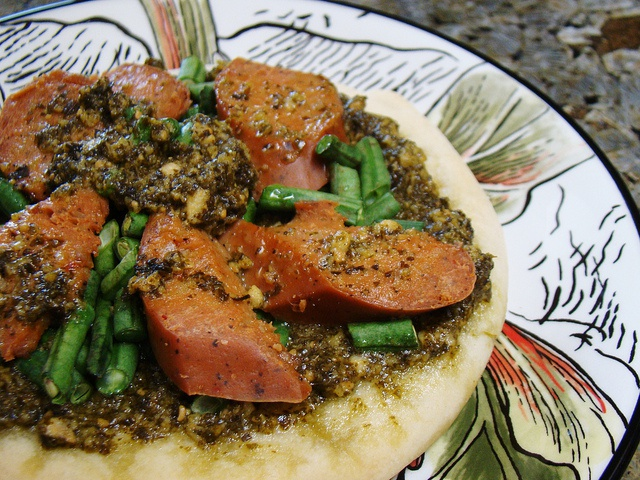Describe the objects in this image and their specific colors. I can see a pizza in gray, brown, black, maroon, and olive tones in this image. 